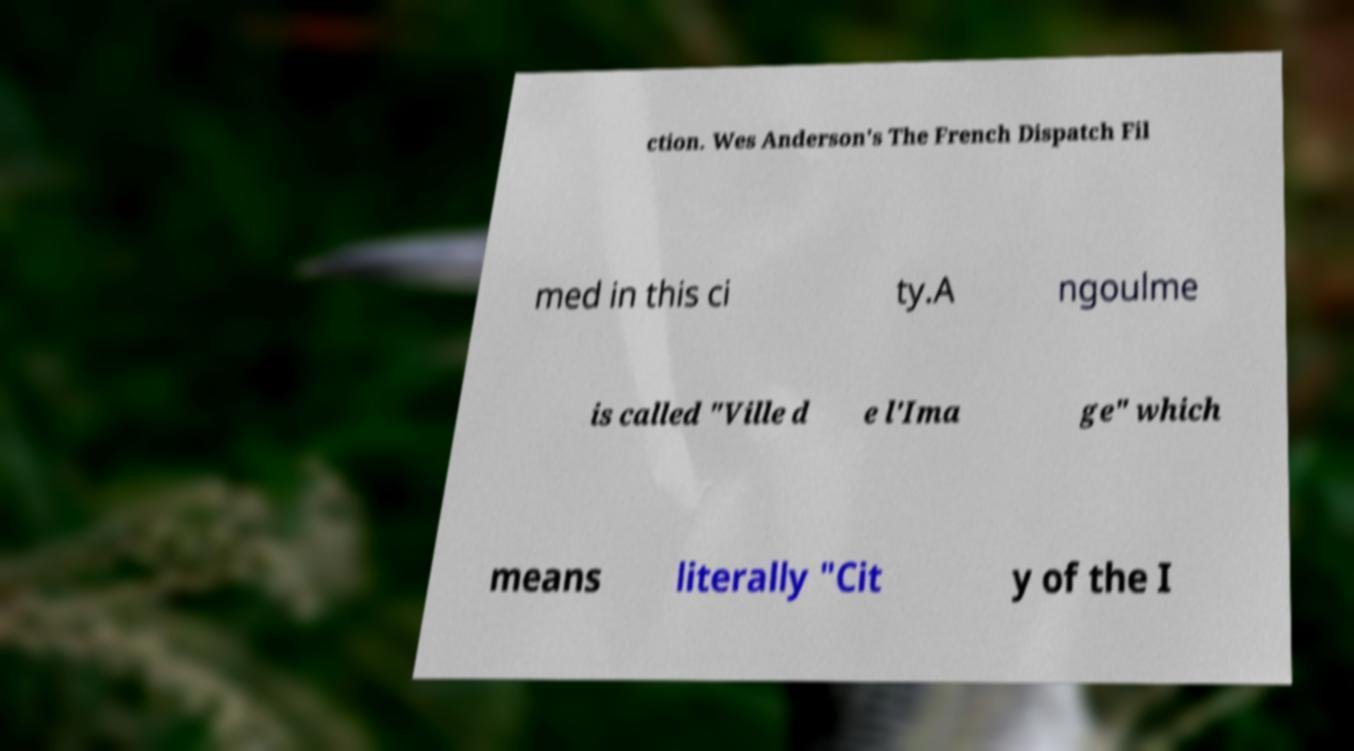Could you assist in decoding the text presented in this image and type it out clearly? ction. Wes Anderson's The French Dispatch Fil med in this ci ty.A ngoulme is called "Ville d e l'Ima ge" which means literally "Cit y of the I 